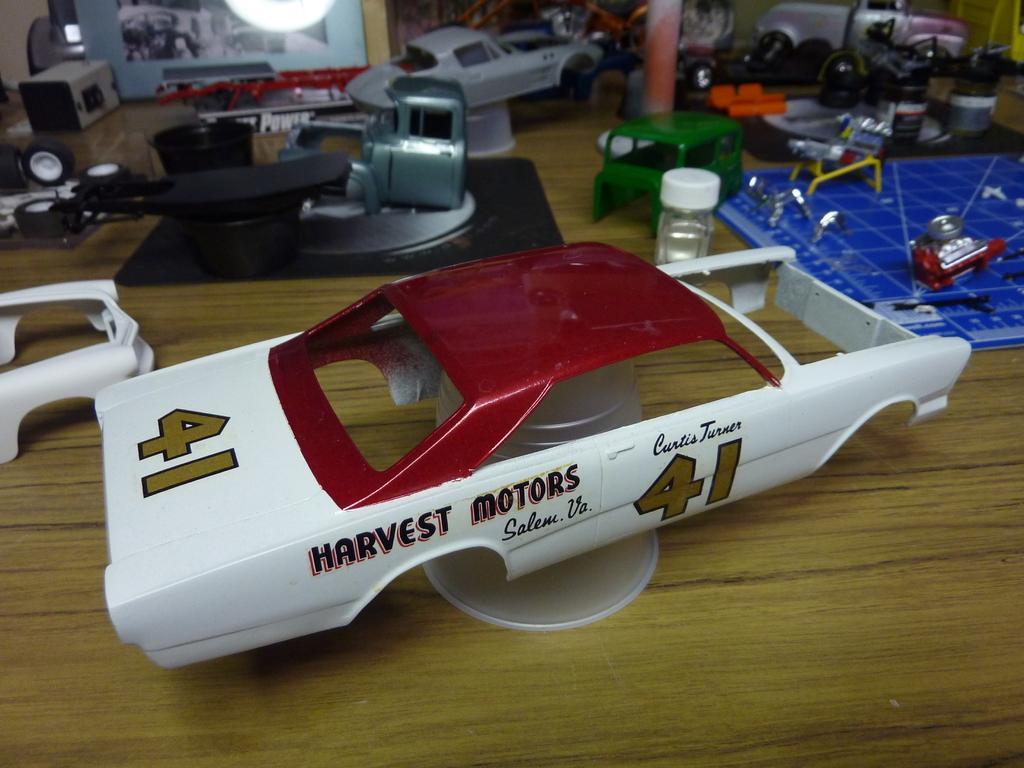How would you summarize this image in a sentence or two? In this picture we can see toys on the wooden surface. 